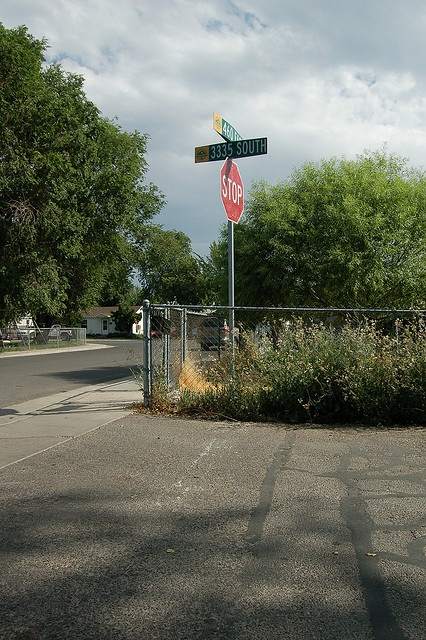Describe the objects in this image and their specific colors. I can see stop sign in darkgray, salmon, brown, ivory, and lightpink tones, car in darkgray, black, gray, darkgreen, and maroon tones, car in darkgray, black, and gray tones, and car in darkgray, gray, black, and darkgreen tones in this image. 